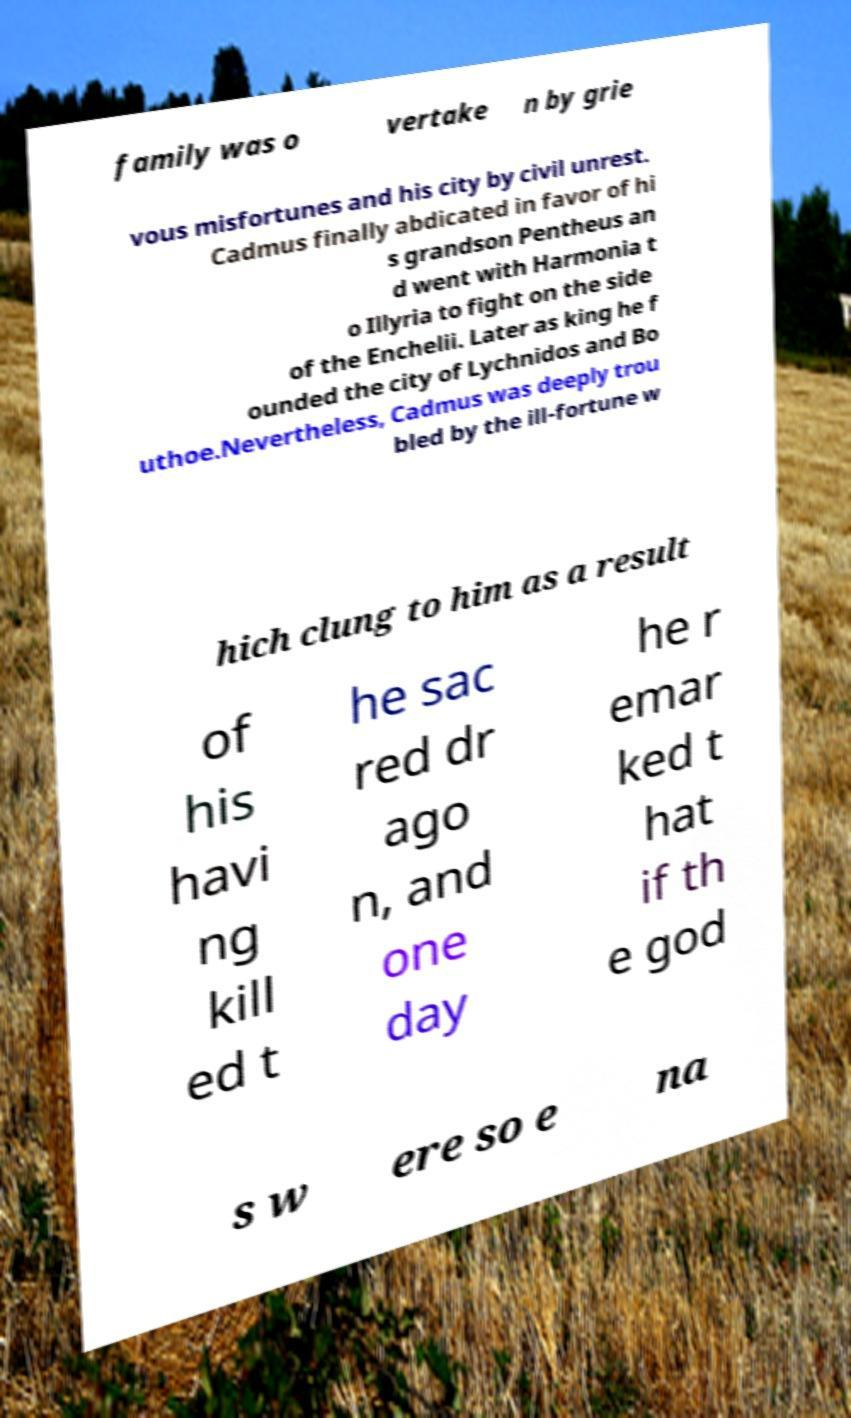For documentation purposes, I need the text within this image transcribed. Could you provide that? family was o vertake n by grie vous misfortunes and his city by civil unrest. Cadmus finally abdicated in favor of hi s grandson Pentheus an d went with Harmonia t o Illyria to fight on the side of the Enchelii. Later as king he f ounded the city of Lychnidos and Bo uthoe.Nevertheless, Cadmus was deeply trou bled by the ill-fortune w hich clung to him as a result of his havi ng kill ed t he sac red dr ago n, and one day he r emar ked t hat if th e god s w ere so e na 